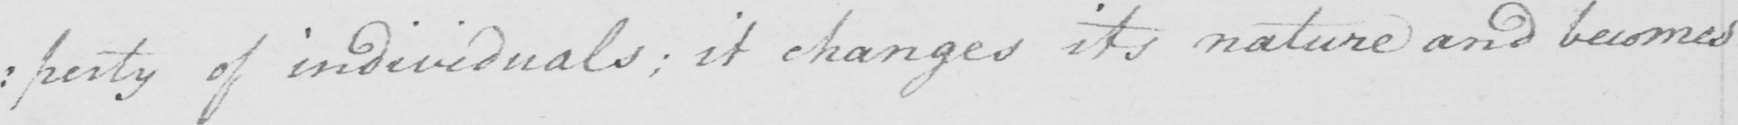Please transcribe the handwritten text in this image. : perty of individuals ; it changes its nature and becomes 